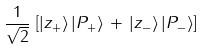<formula> <loc_0><loc_0><loc_500><loc_500>\frac { 1 } { \sqrt { 2 } } \, \left [ | z _ { + } \rangle \, | P _ { + } \rangle \, + \, | z _ { - } \rangle \, | P _ { - } \rangle \right ]</formula> 